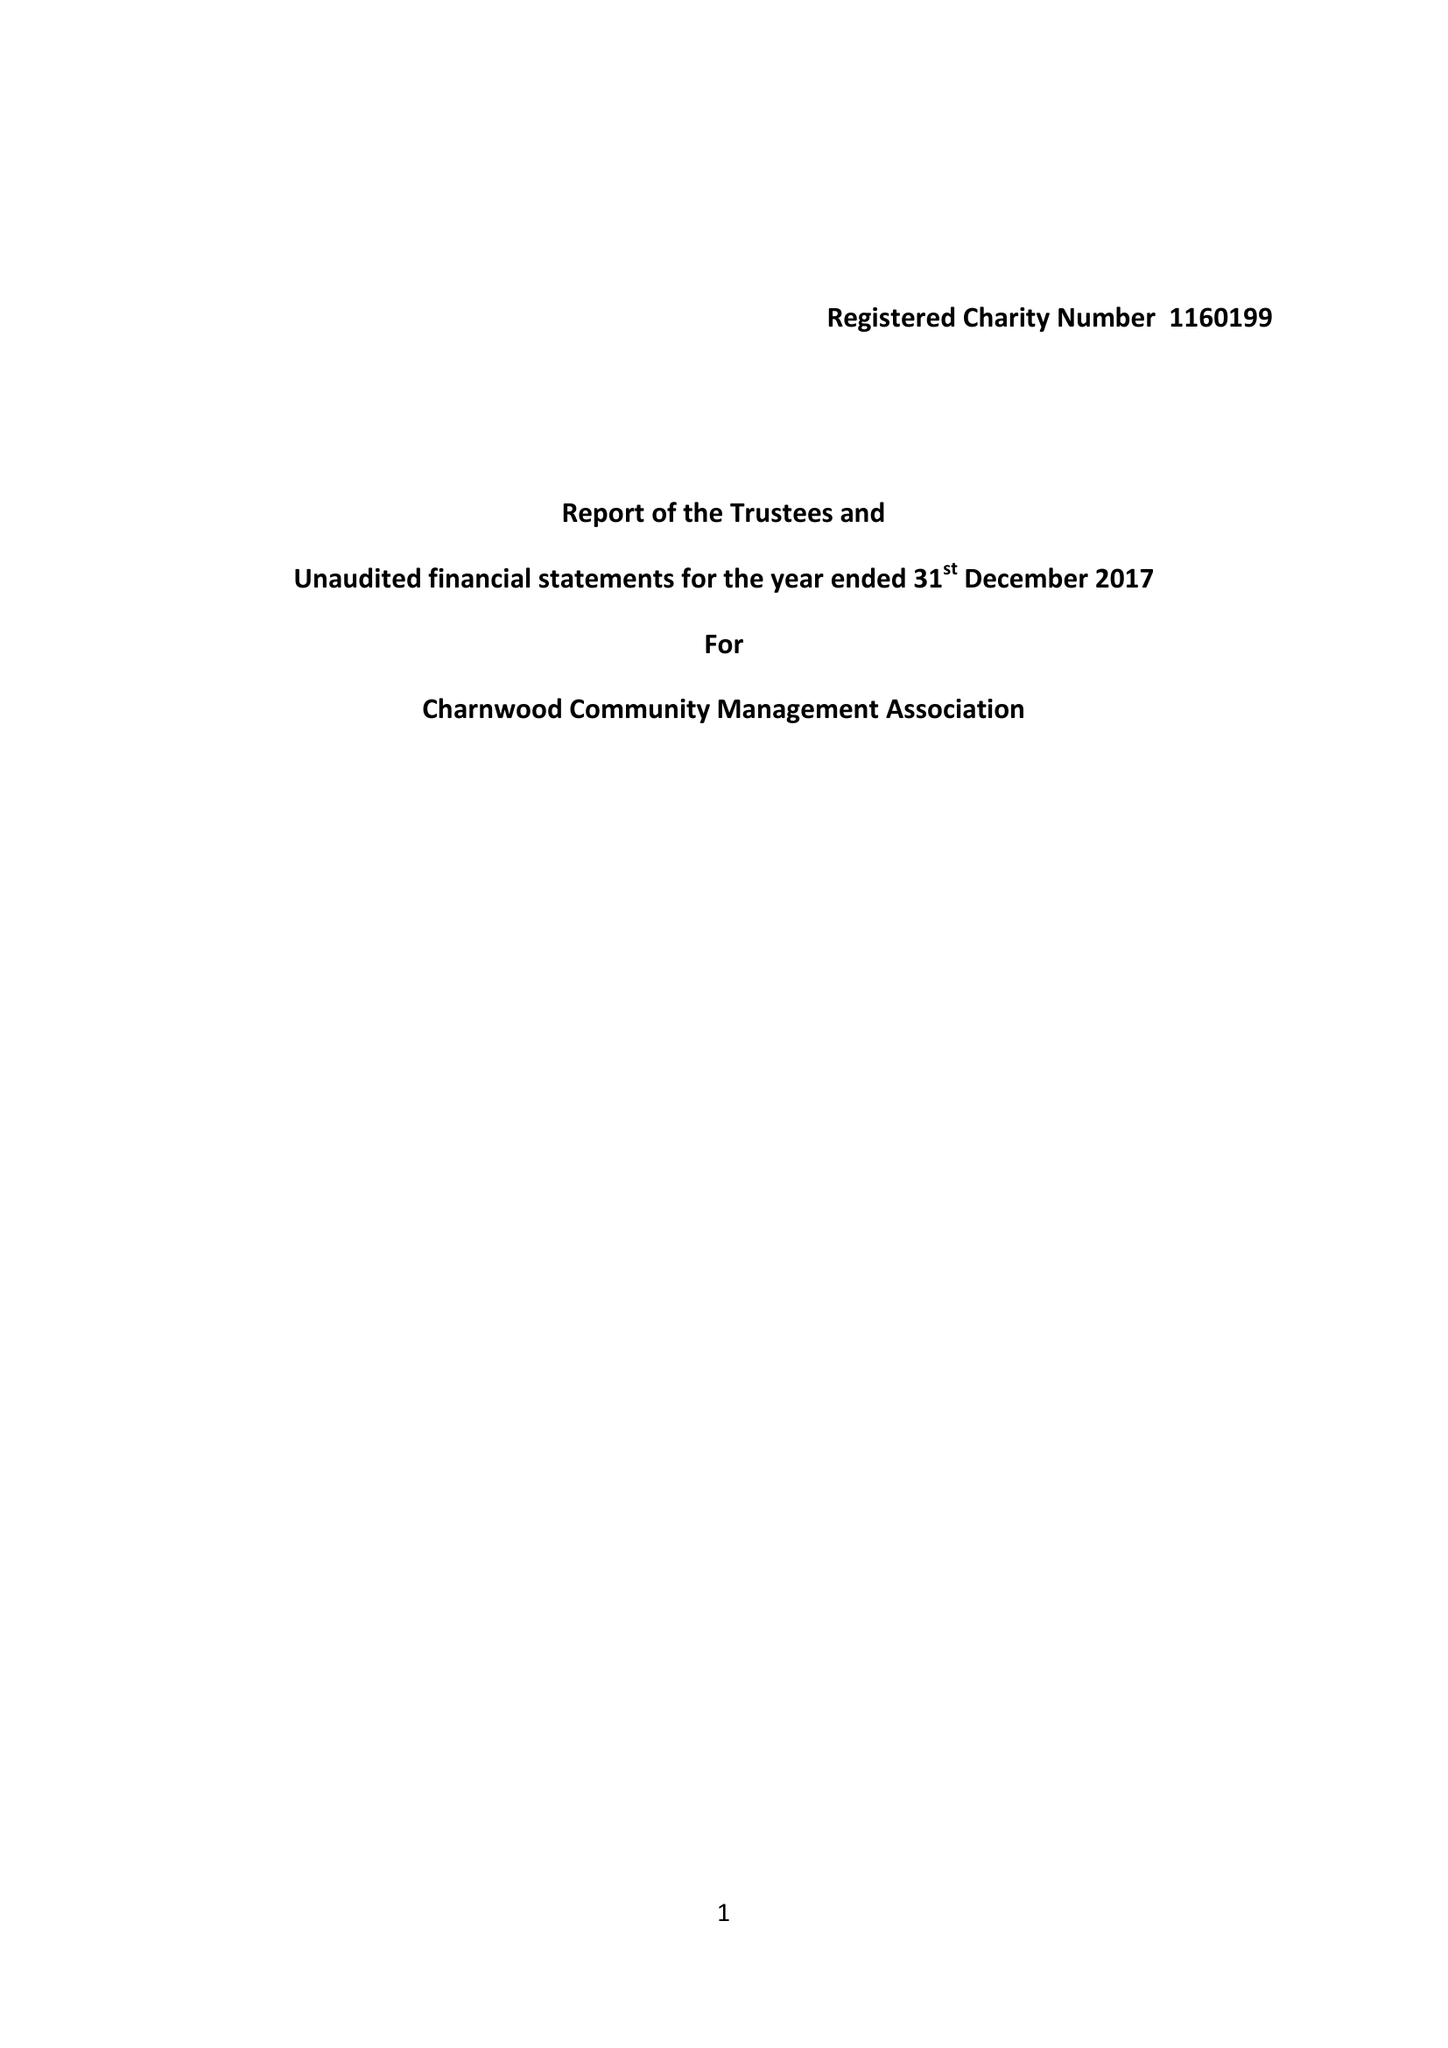What is the value for the address__street_line?
Answer the question using a single word or phrase. 23 WEST HILL 